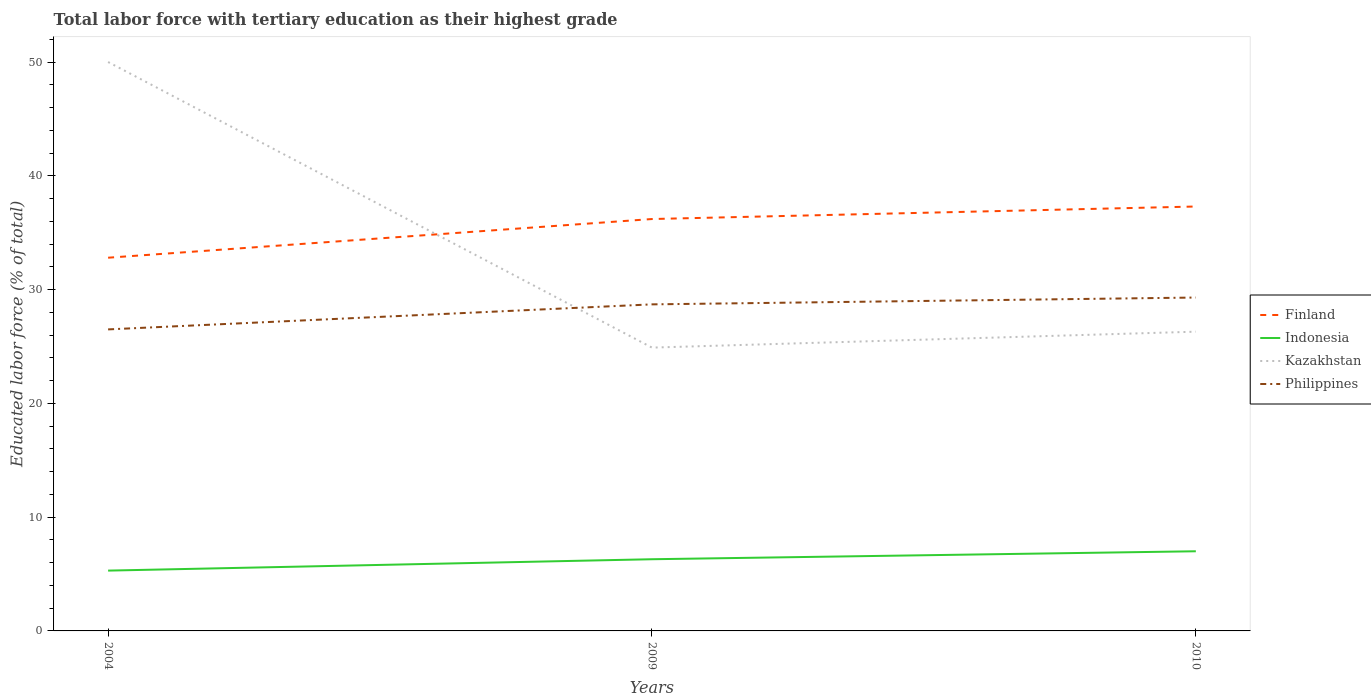Does the line corresponding to Kazakhstan intersect with the line corresponding to Indonesia?
Your answer should be very brief. No. What is the total percentage of male labor force with tertiary education in Kazakhstan in the graph?
Your answer should be very brief. 23.7. What is the difference between the highest and the second highest percentage of male labor force with tertiary education in Philippines?
Give a very brief answer. 2.8. What is the difference between the highest and the lowest percentage of male labor force with tertiary education in Finland?
Offer a very short reply. 2. Is the percentage of male labor force with tertiary education in Indonesia strictly greater than the percentage of male labor force with tertiary education in Finland over the years?
Offer a terse response. Yes. How many years are there in the graph?
Offer a very short reply. 3. What is the difference between two consecutive major ticks on the Y-axis?
Provide a succinct answer. 10. Does the graph contain any zero values?
Make the answer very short. No. What is the title of the graph?
Keep it short and to the point. Total labor force with tertiary education as their highest grade. What is the label or title of the Y-axis?
Offer a very short reply. Educated labor force (% of total). What is the Educated labor force (% of total) in Finland in 2004?
Provide a short and direct response. 32.8. What is the Educated labor force (% of total) of Indonesia in 2004?
Provide a succinct answer. 5.3. What is the Educated labor force (% of total) of Kazakhstan in 2004?
Your answer should be very brief. 50. What is the Educated labor force (% of total) in Philippines in 2004?
Your answer should be compact. 26.5. What is the Educated labor force (% of total) of Finland in 2009?
Make the answer very short. 36.2. What is the Educated labor force (% of total) of Indonesia in 2009?
Offer a terse response. 6.3. What is the Educated labor force (% of total) in Kazakhstan in 2009?
Ensure brevity in your answer.  24.9. What is the Educated labor force (% of total) in Philippines in 2009?
Offer a terse response. 28.7. What is the Educated labor force (% of total) of Finland in 2010?
Make the answer very short. 37.3. What is the Educated labor force (% of total) in Kazakhstan in 2010?
Provide a short and direct response. 26.3. What is the Educated labor force (% of total) of Philippines in 2010?
Your answer should be very brief. 29.3. Across all years, what is the maximum Educated labor force (% of total) of Finland?
Offer a very short reply. 37.3. Across all years, what is the maximum Educated labor force (% of total) of Indonesia?
Ensure brevity in your answer.  7. Across all years, what is the maximum Educated labor force (% of total) of Kazakhstan?
Offer a terse response. 50. Across all years, what is the maximum Educated labor force (% of total) of Philippines?
Offer a very short reply. 29.3. Across all years, what is the minimum Educated labor force (% of total) of Finland?
Give a very brief answer. 32.8. Across all years, what is the minimum Educated labor force (% of total) in Indonesia?
Provide a succinct answer. 5.3. Across all years, what is the minimum Educated labor force (% of total) of Kazakhstan?
Offer a very short reply. 24.9. What is the total Educated labor force (% of total) of Finland in the graph?
Make the answer very short. 106.3. What is the total Educated labor force (% of total) in Kazakhstan in the graph?
Your answer should be very brief. 101.2. What is the total Educated labor force (% of total) in Philippines in the graph?
Ensure brevity in your answer.  84.5. What is the difference between the Educated labor force (% of total) in Finland in 2004 and that in 2009?
Keep it short and to the point. -3.4. What is the difference between the Educated labor force (% of total) in Kazakhstan in 2004 and that in 2009?
Your answer should be very brief. 25.1. What is the difference between the Educated labor force (% of total) in Kazakhstan in 2004 and that in 2010?
Offer a very short reply. 23.7. What is the difference between the Educated labor force (% of total) in Philippines in 2004 and that in 2010?
Your response must be concise. -2.8. What is the difference between the Educated labor force (% of total) of Indonesia in 2009 and that in 2010?
Your answer should be very brief. -0.7. What is the difference between the Educated labor force (% of total) of Philippines in 2009 and that in 2010?
Offer a terse response. -0.6. What is the difference between the Educated labor force (% of total) of Indonesia in 2004 and the Educated labor force (% of total) of Kazakhstan in 2009?
Ensure brevity in your answer.  -19.6. What is the difference between the Educated labor force (% of total) of Indonesia in 2004 and the Educated labor force (% of total) of Philippines in 2009?
Offer a very short reply. -23.4. What is the difference between the Educated labor force (% of total) in Kazakhstan in 2004 and the Educated labor force (% of total) in Philippines in 2009?
Give a very brief answer. 21.3. What is the difference between the Educated labor force (% of total) of Finland in 2004 and the Educated labor force (% of total) of Indonesia in 2010?
Your response must be concise. 25.8. What is the difference between the Educated labor force (% of total) of Finland in 2004 and the Educated labor force (% of total) of Philippines in 2010?
Your response must be concise. 3.5. What is the difference between the Educated labor force (% of total) of Kazakhstan in 2004 and the Educated labor force (% of total) of Philippines in 2010?
Make the answer very short. 20.7. What is the difference between the Educated labor force (% of total) of Finland in 2009 and the Educated labor force (% of total) of Indonesia in 2010?
Offer a very short reply. 29.2. What is the difference between the Educated labor force (% of total) in Finland in 2009 and the Educated labor force (% of total) in Philippines in 2010?
Offer a very short reply. 6.9. What is the difference between the Educated labor force (% of total) of Kazakhstan in 2009 and the Educated labor force (% of total) of Philippines in 2010?
Keep it short and to the point. -4.4. What is the average Educated labor force (% of total) of Finland per year?
Give a very brief answer. 35.43. What is the average Educated labor force (% of total) of Kazakhstan per year?
Make the answer very short. 33.73. What is the average Educated labor force (% of total) in Philippines per year?
Offer a terse response. 28.17. In the year 2004, what is the difference between the Educated labor force (% of total) in Finland and Educated labor force (% of total) in Indonesia?
Your answer should be very brief. 27.5. In the year 2004, what is the difference between the Educated labor force (% of total) in Finland and Educated labor force (% of total) in Kazakhstan?
Provide a short and direct response. -17.2. In the year 2004, what is the difference between the Educated labor force (% of total) in Indonesia and Educated labor force (% of total) in Kazakhstan?
Provide a succinct answer. -44.7. In the year 2004, what is the difference between the Educated labor force (% of total) of Indonesia and Educated labor force (% of total) of Philippines?
Keep it short and to the point. -21.2. In the year 2004, what is the difference between the Educated labor force (% of total) in Kazakhstan and Educated labor force (% of total) in Philippines?
Make the answer very short. 23.5. In the year 2009, what is the difference between the Educated labor force (% of total) of Finland and Educated labor force (% of total) of Indonesia?
Offer a very short reply. 29.9. In the year 2009, what is the difference between the Educated labor force (% of total) of Finland and Educated labor force (% of total) of Kazakhstan?
Your response must be concise. 11.3. In the year 2009, what is the difference between the Educated labor force (% of total) of Finland and Educated labor force (% of total) of Philippines?
Offer a very short reply. 7.5. In the year 2009, what is the difference between the Educated labor force (% of total) of Indonesia and Educated labor force (% of total) of Kazakhstan?
Offer a very short reply. -18.6. In the year 2009, what is the difference between the Educated labor force (% of total) in Indonesia and Educated labor force (% of total) in Philippines?
Your response must be concise. -22.4. In the year 2009, what is the difference between the Educated labor force (% of total) in Kazakhstan and Educated labor force (% of total) in Philippines?
Your answer should be very brief. -3.8. In the year 2010, what is the difference between the Educated labor force (% of total) in Finland and Educated labor force (% of total) in Indonesia?
Provide a short and direct response. 30.3. In the year 2010, what is the difference between the Educated labor force (% of total) in Finland and Educated labor force (% of total) in Kazakhstan?
Your response must be concise. 11. In the year 2010, what is the difference between the Educated labor force (% of total) in Indonesia and Educated labor force (% of total) in Kazakhstan?
Your answer should be very brief. -19.3. In the year 2010, what is the difference between the Educated labor force (% of total) of Indonesia and Educated labor force (% of total) of Philippines?
Your answer should be compact. -22.3. In the year 2010, what is the difference between the Educated labor force (% of total) of Kazakhstan and Educated labor force (% of total) of Philippines?
Ensure brevity in your answer.  -3. What is the ratio of the Educated labor force (% of total) of Finland in 2004 to that in 2009?
Make the answer very short. 0.91. What is the ratio of the Educated labor force (% of total) of Indonesia in 2004 to that in 2009?
Ensure brevity in your answer.  0.84. What is the ratio of the Educated labor force (% of total) in Kazakhstan in 2004 to that in 2009?
Make the answer very short. 2.01. What is the ratio of the Educated labor force (% of total) of Philippines in 2004 to that in 2009?
Your answer should be very brief. 0.92. What is the ratio of the Educated labor force (% of total) of Finland in 2004 to that in 2010?
Offer a very short reply. 0.88. What is the ratio of the Educated labor force (% of total) of Indonesia in 2004 to that in 2010?
Offer a very short reply. 0.76. What is the ratio of the Educated labor force (% of total) of Kazakhstan in 2004 to that in 2010?
Provide a succinct answer. 1.9. What is the ratio of the Educated labor force (% of total) of Philippines in 2004 to that in 2010?
Your answer should be very brief. 0.9. What is the ratio of the Educated labor force (% of total) in Finland in 2009 to that in 2010?
Keep it short and to the point. 0.97. What is the ratio of the Educated labor force (% of total) of Indonesia in 2009 to that in 2010?
Provide a short and direct response. 0.9. What is the ratio of the Educated labor force (% of total) in Kazakhstan in 2009 to that in 2010?
Offer a very short reply. 0.95. What is the ratio of the Educated labor force (% of total) of Philippines in 2009 to that in 2010?
Your response must be concise. 0.98. What is the difference between the highest and the second highest Educated labor force (% of total) of Kazakhstan?
Provide a short and direct response. 23.7. What is the difference between the highest and the lowest Educated labor force (% of total) of Indonesia?
Provide a short and direct response. 1.7. What is the difference between the highest and the lowest Educated labor force (% of total) in Kazakhstan?
Make the answer very short. 25.1. What is the difference between the highest and the lowest Educated labor force (% of total) of Philippines?
Your response must be concise. 2.8. 